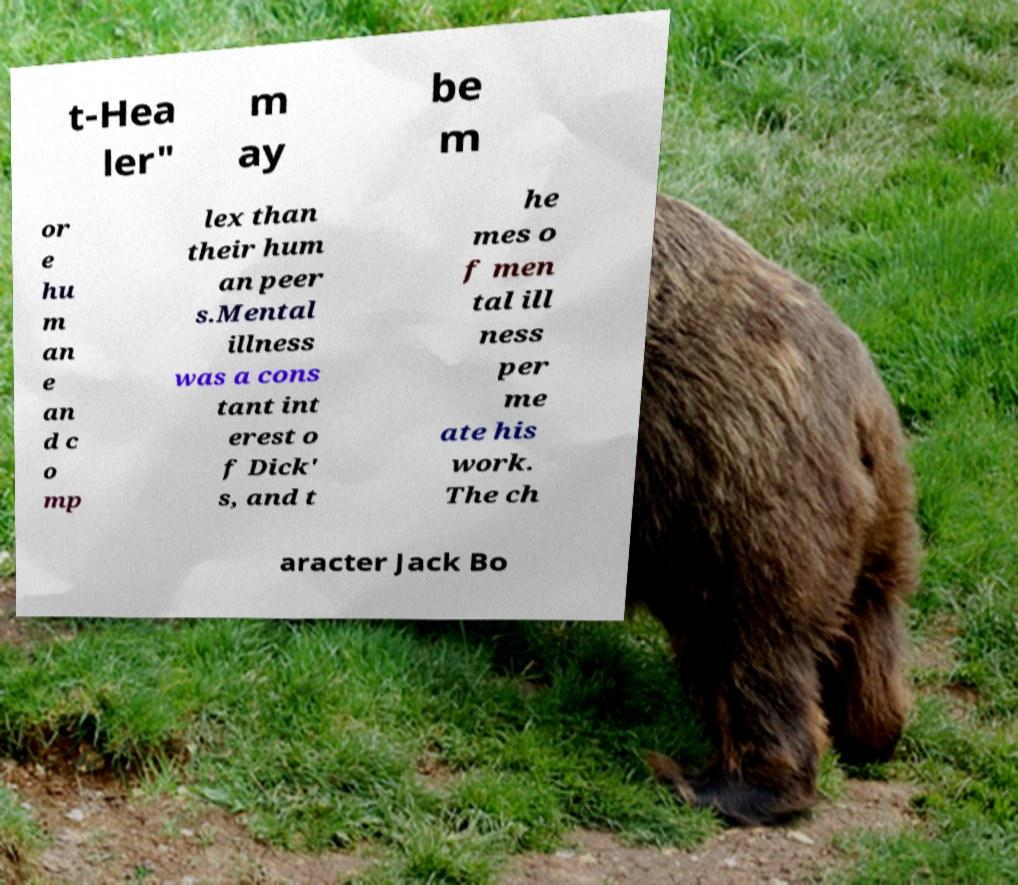Please identify and transcribe the text found in this image. t-Hea ler" m ay be m or e hu m an e an d c o mp lex than their hum an peer s.Mental illness was a cons tant int erest o f Dick' s, and t he mes o f men tal ill ness per me ate his work. The ch aracter Jack Bo 